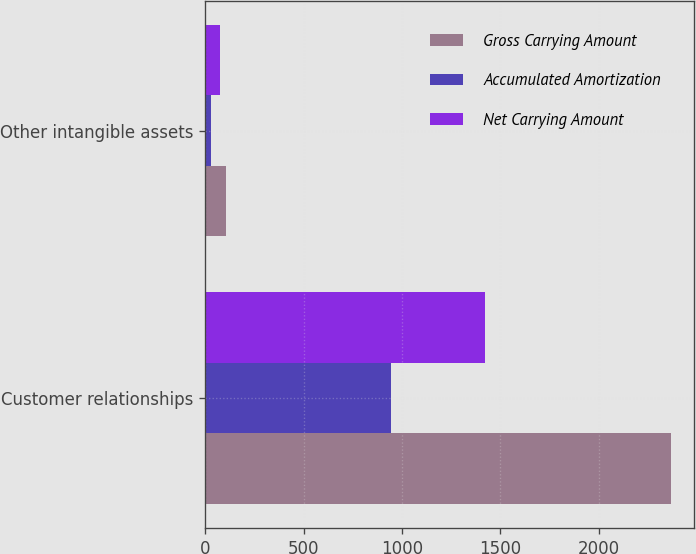Convert chart to OTSL. <chart><loc_0><loc_0><loc_500><loc_500><stacked_bar_chart><ecel><fcel>Customer relationships<fcel>Other intangible assets<nl><fcel>Gross Carrying Amount<fcel>2368<fcel>105<nl><fcel>Accumulated Amortization<fcel>944<fcel>29<nl><fcel>Net Carrying Amount<fcel>1424<fcel>76<nl></chart> 